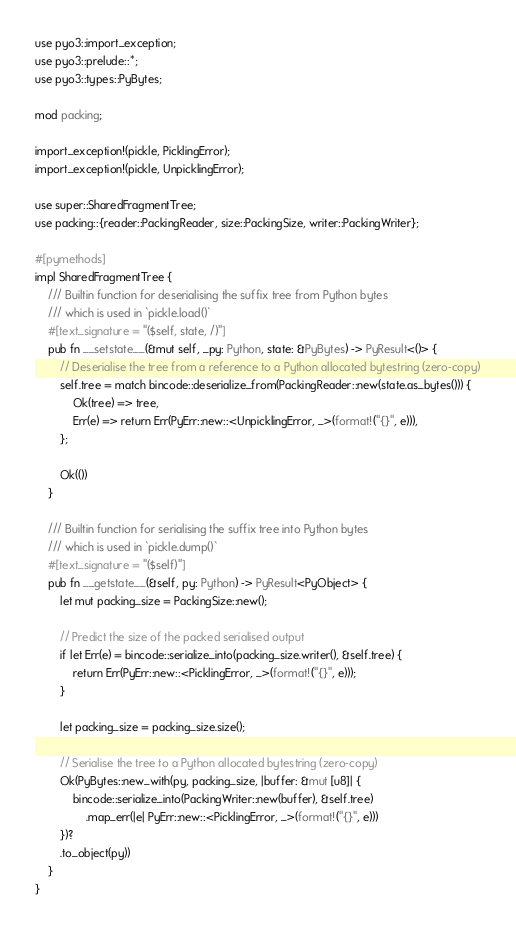<code> <loc_0><loc_0><loc_500><loc_500><_Rust_>use pyo3::import_exception;
use pyo3::prelude::*;
use pyo3::types::PyBytes;

mod packing;

import_exception!(pickle, PicklingError);
import_exception!(pickle, UnpicklingError);

use super::SharedFragmentTree;
use packing::{reader::PackingReader, size::PackingSize, writer::PackingWriter};

#[pymethods]
impl SharedFragmentTree {
    /// Builtin function for deserialising the suffix tree from Python bytes
    /// which is used in `pickle.load()`
    #[text_signature = "($self, state, /)"]
    pub fn __setstate__(&mut self, _py: Python, state: &PyBytes) -> PyResult<()> {
        // Deserialise the tree from a reference to a Python allocated bytestring (zero-copy)
        self.tree = match bincode::deserialize_from(PackingReader::new(state.as_bytes())) {
            Ok(tree) => tree,
            Err(e) => return Err(PyErr::new::<UnpicklingError, _>(format!("{}", e))),
        };

        Ok(())
    }

    /// Builtin function for serialising the suffix tree into Python bytes
    /// which is used in `pickle.dump()`
    #[text_signature = "($self)"]
    pub fn __getstate__(&self, py: Python) -> PyResult<PyObject> {
        let mut packing_size = PackingSize::new();

        // Predict the size of the packed serialised output
        if let Err(e) = bincode::serialize_into(packing_size.writer(), &self.tree) {
            return Err(PyErr::new::<PicklingError, _>(format!("{}", e)));
        }

        let packing_size = packing_size.size();

        // Serialise the tree to a Python allocated bytestring (zero-copy)
        Ok(PyBytes::new_with(py, packing_size, |buffer: &mut [u8]| {
            bincode::serialize_into(PackingWriter::new(buffer), &self.tree)
                .map_err(|e| PyErr::new::<PicklingError, _>(format!("{}", e)))
        })?
        .to_object(py))
    }
}
</code> 